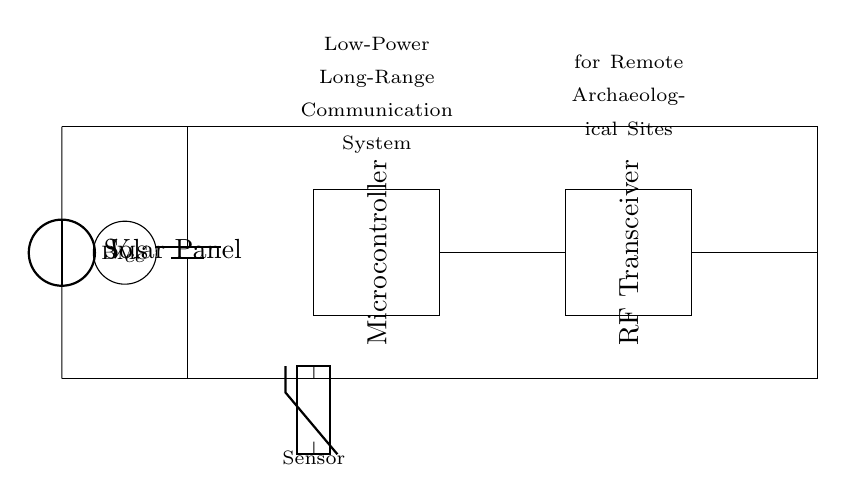What is the main power source in this circuit? The main power source is the solar panel, which provides energy for the circuit. It connects to the overall circuit design, ensuring it has the necessary energy input for operation.
Answer: Solar panel What component connects the microcontroller to the RF transceiver? The microcontroller is directly connected to the RF transceiver through a signal line. This connection is necessary for data transmission between the two components.
Answer: Signal line What does BMS stand for in this circuit? BMS stands for Battery Management System. It is indicated by the circular symbol in the circuit and is essential for managing the battery's performance and safety.
Answer: Battery Management System What type of antenna is used in this communication system? The circuit diagram utilizes an antenna for radio frequency (RF) communication. This type of antenna is crucial for long-range wireless signals in remote locations.
Answer: Antenna How does the circuit manage power supply when sunlight is insufficient? The circuit likely uses the battery management system to store energy from the solar panel and supply power when solar energy is inadequate. This functionality allows for continuous operation, even during cloudy conditions.
Answer: Battery management What is the purpose of the thermistor in this circuit? The thermistor serves as a temperature sensor, providing environmental data to the microcontroller. This information can be crucial for monitoring conditions at excavation sites or providing data for further analysis.
Answer: Temperature sensor 